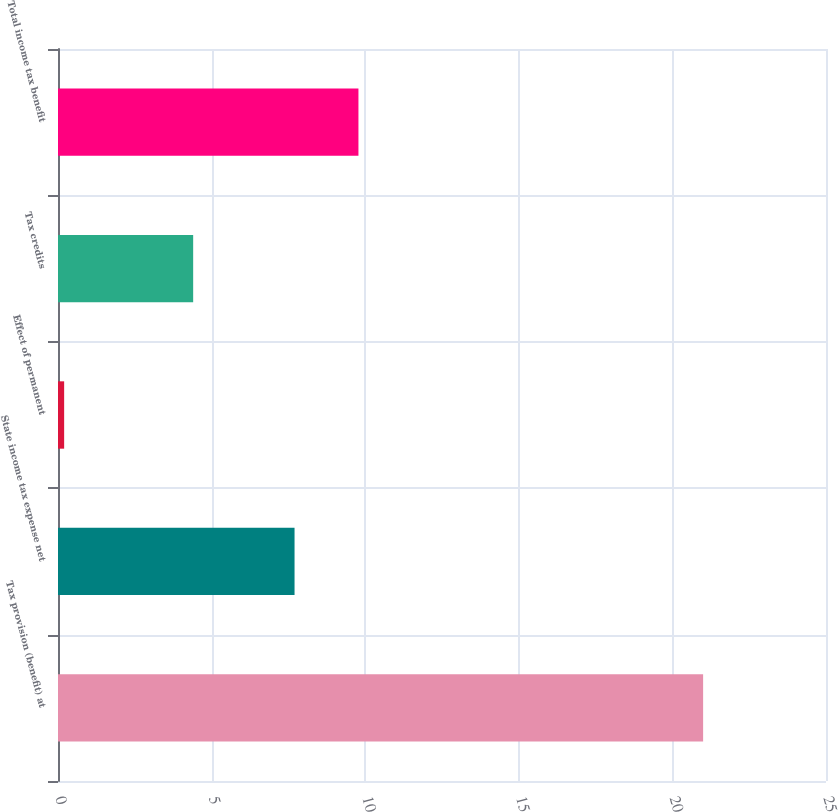<chart> <loc_0><loc_0><loc_500><loc_500><bar_chart><fcel>Tax provision (benefit) at<fcel>State income tax expense net<fcel>Effect of permanent<fcel>Tax credits<fcel>Total income tax benefit<nl><fcel>21<fcel>7.7<fcel>0.2<fcel>4.4<fcel>9.78<nl></chart> 